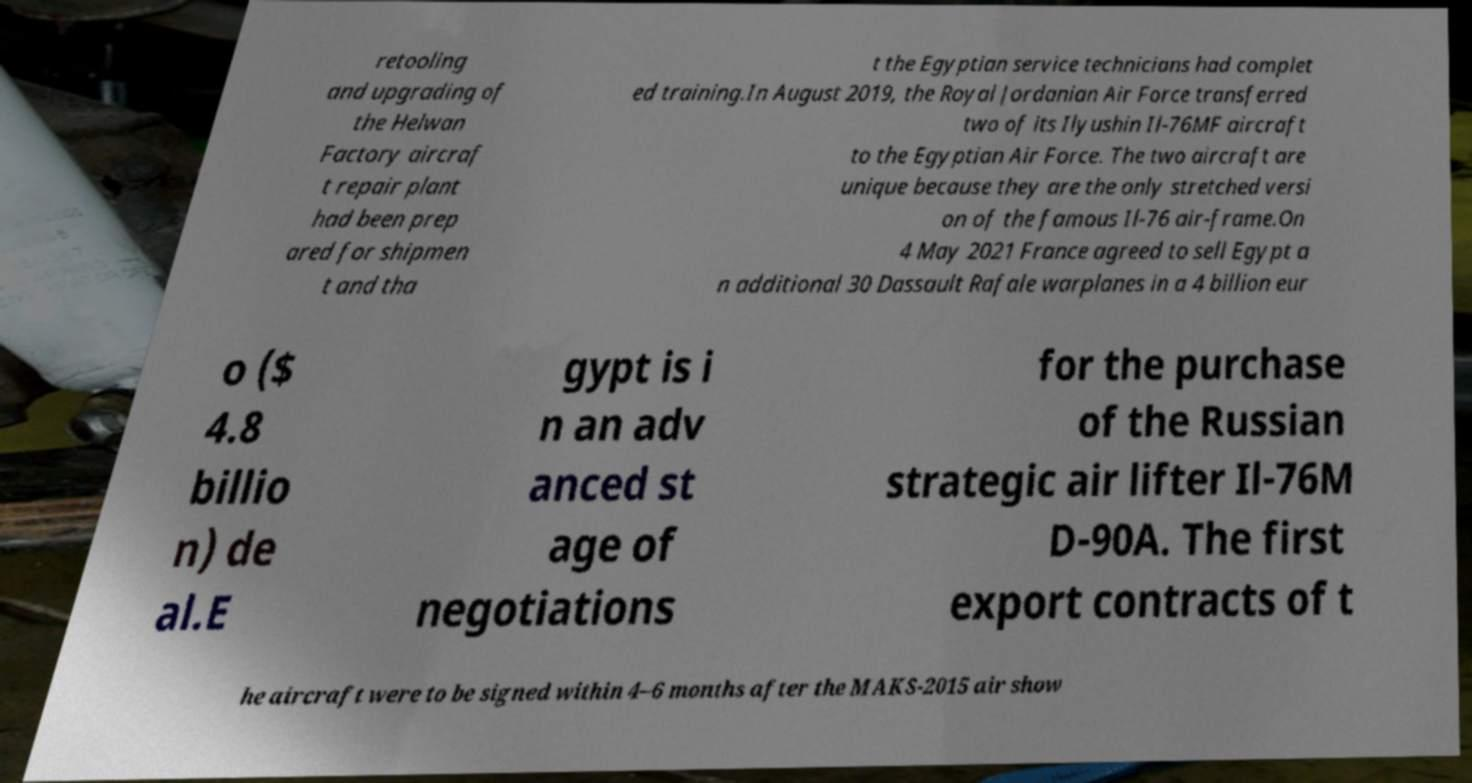I need the written content from this picture converted into text. Can you do that? retooling and upgrading of the Helwan Factory aircraf t repair plant had been prep ared for shipmen t and tha t the Egyptian service technicians had complet ed training.In August 2019, the Royal Jordanian Air Force transferred two of its Ilyushin Il-76MF aircraft to the Egyptian Air Force. The two aircraft are unique because they are the only stretched versi on of the famous Il-76 air-frame.On 4 May 2021 France agreed to sell Egypt a n additional 30 Dassault Rafale warplanes in a 4 billion eur o ($ 4.8 billio n) de al.E gypt is i n an adv anced st age of negotiations for the purchase of the Russian strategic air lifter Il-76M D-90A. The first export contracts of t he aircraft were to be signed within 4–6 months after the MAKS-2015 air show 